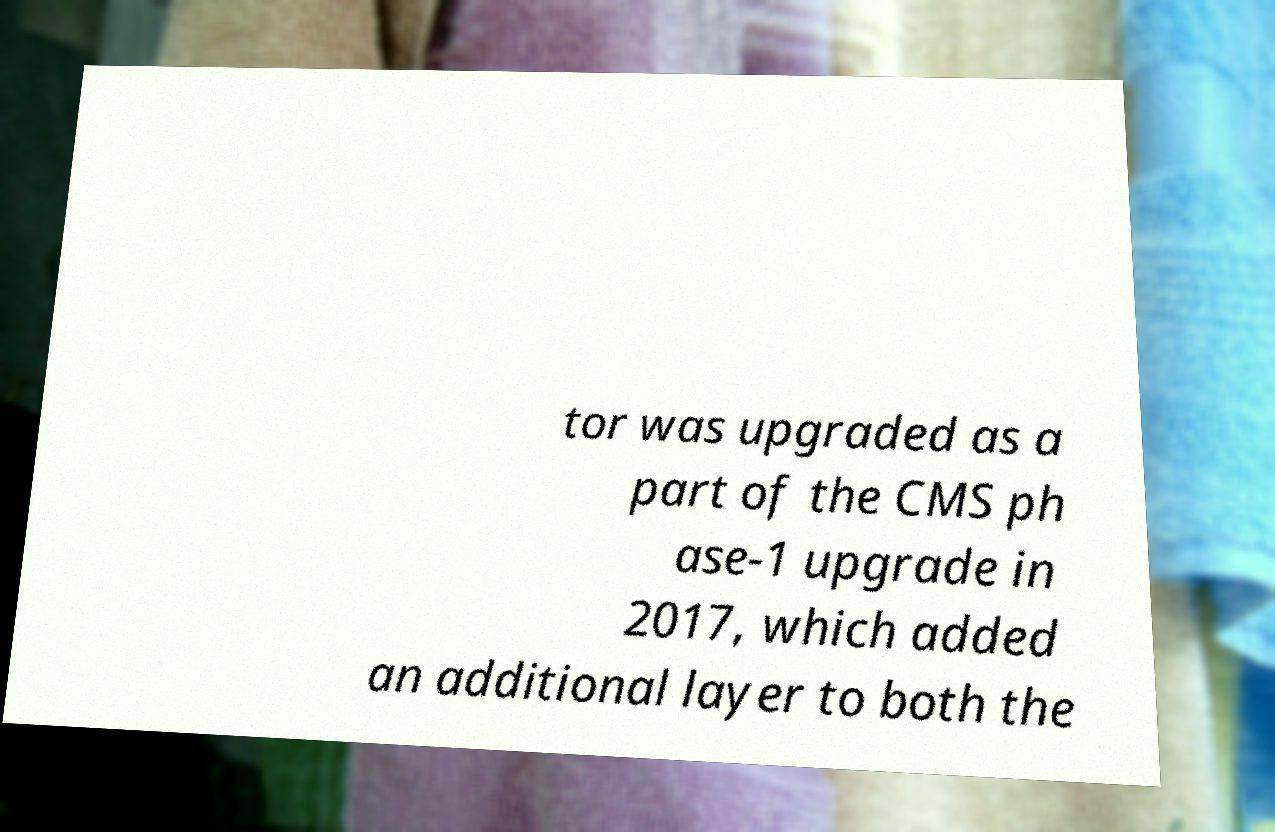For documentation purposes, I need the text within this image transcribed. Could you provide that? tor was upgraded as a part of the CMS ph ase-1 upgrade in 2017, which added an additional layer to both the 